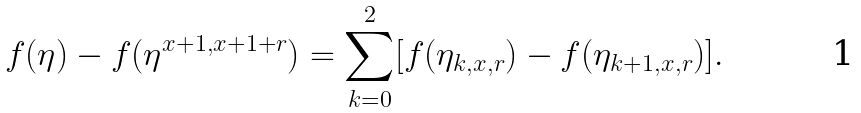<formula> <loc_0><loc_0><loc_500><loc_500>f ( \eta ) - f ( \eta ^ { x + 1 , x + 1 + r } ) = \sum _ { k = 0 } ^ { 2 } [ f ( \eta _ { k , x , r } ) - f ( \eta _ { k + 1 , x , r } ) ] .</formula> 